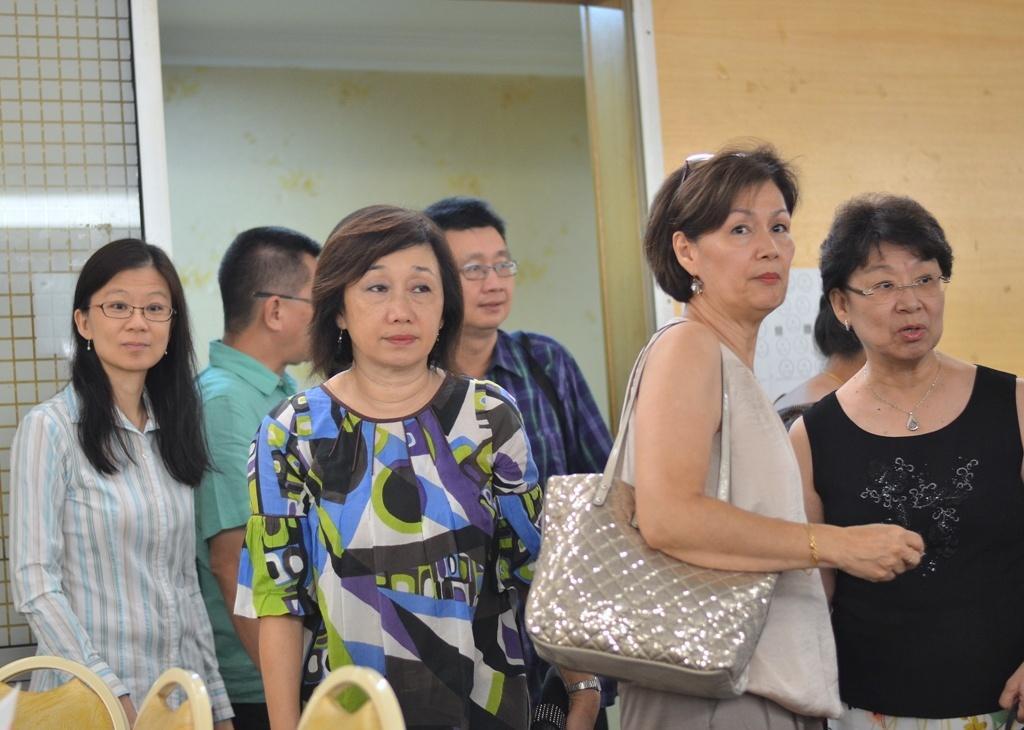Please provide a concise description of this image. In the image there are few men standing in the front and behind there are two men standing, on the left side there are three chairs and behind them there is a wall with entrance in the middle. 